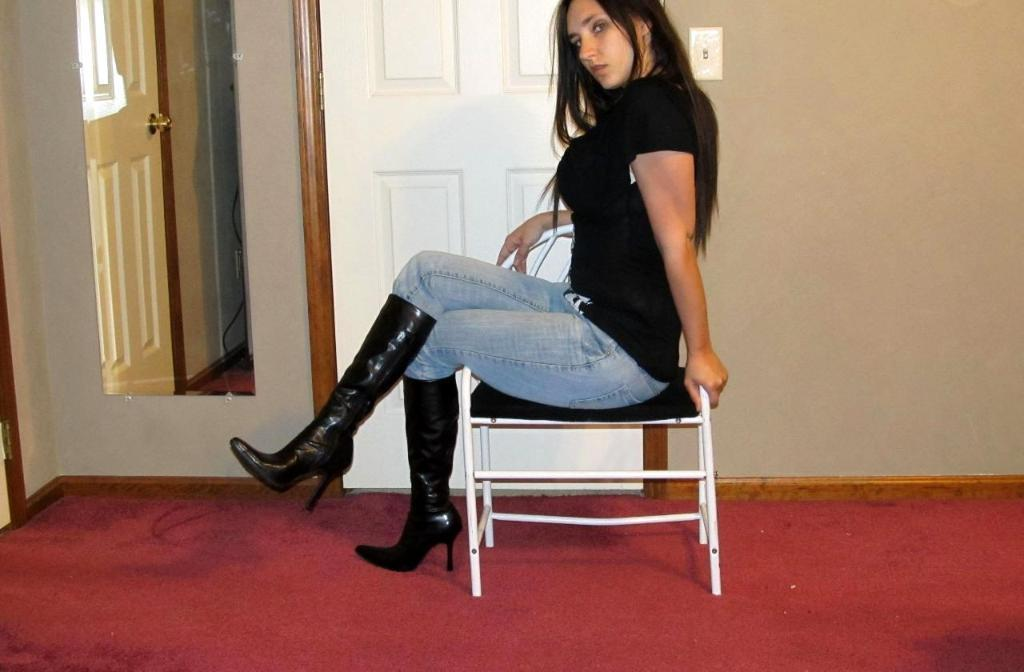What is the woman doing in the image? The woman is sitting on a chair in the image. What is the color of the carpet beneath the chair? The chair is on a red carpet. What is located beside the woman? There is a door and a mirror beside the woman. What type of minister is present in the image? There is no minister present in the image. Is there any steam visible in the image? There is no steam visible in the image. 